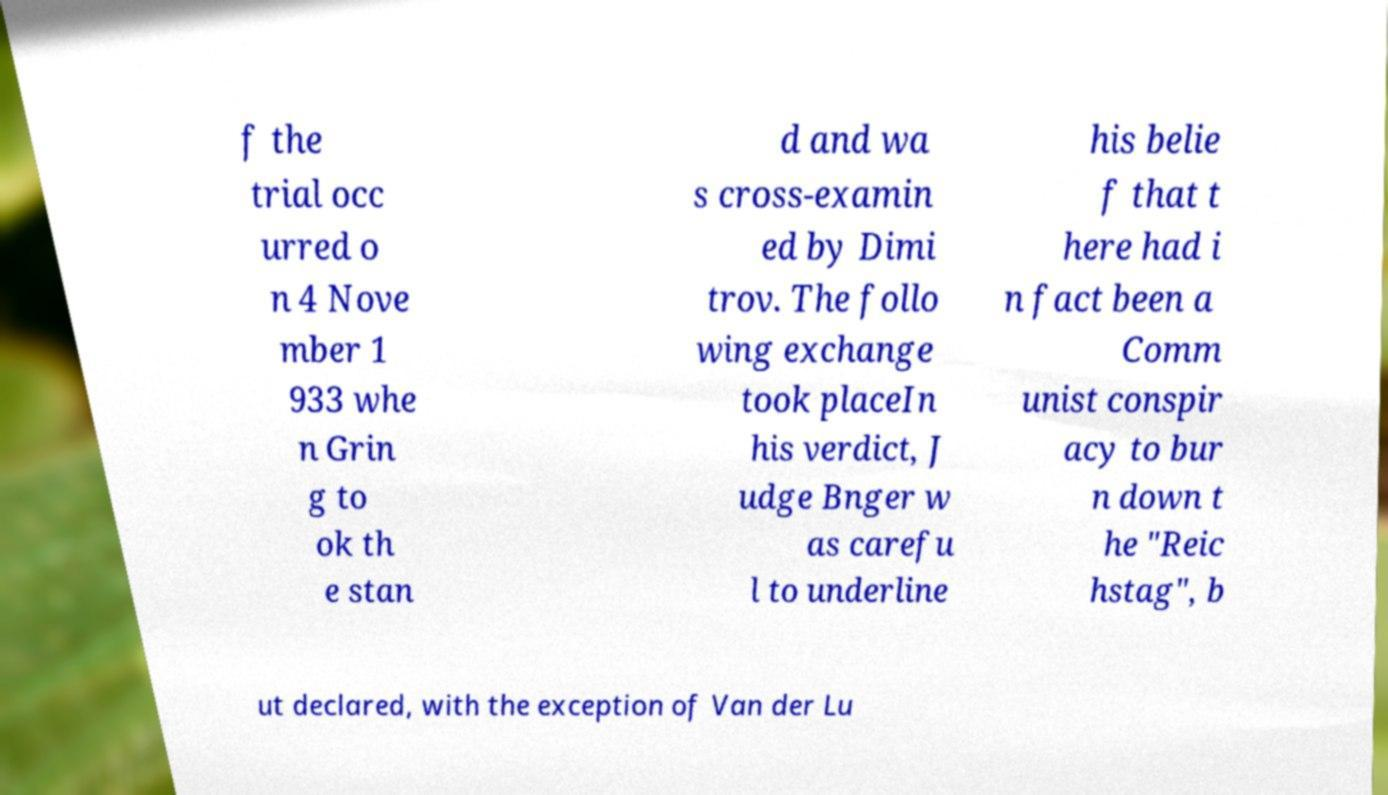Can you read and provide the text displayed in the image?This photo seems to have some interesting text. Can you extract and type it out for me? f the trial occ urred o n 4 Nove mber 1 933 whe n Grin g to ok th e stan d and wa s cross-examin ed by Dimi trov. The follo wing exchange took placeIn his verdict, J udge Bnger w as carefu l to underline his belie f that t here had i n fact been a Comm unist conspir acy to bur n down t he "Reic hstag", b ut declared, with the exception of Van der Lu 